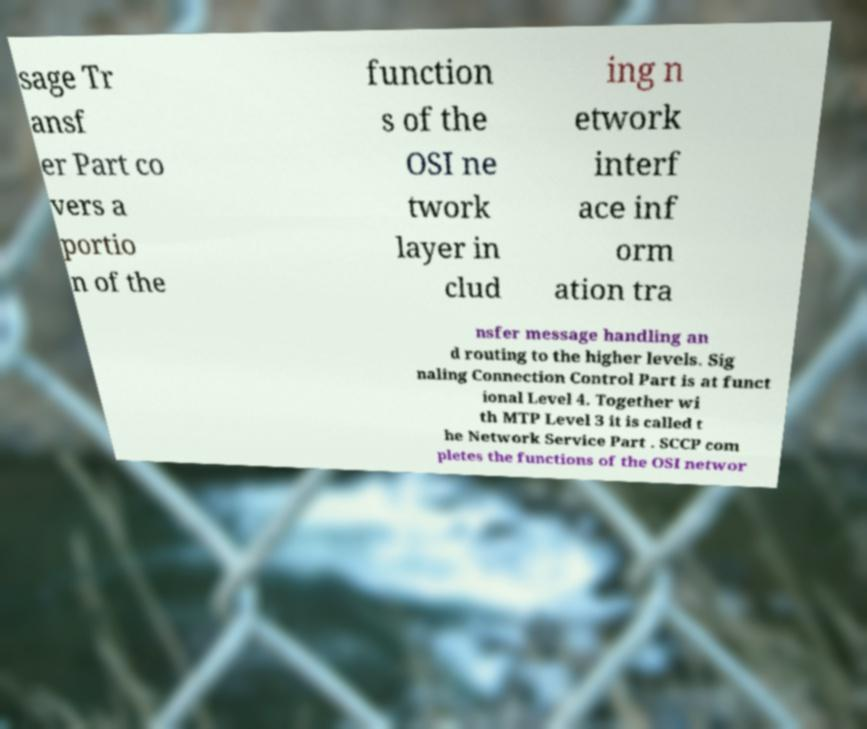Please identify and transcribe the text found in this image. sage Tr ansf er Part co vers a portio n of the function s of the OSI ne twork layer in clud ing n etwork interf ace inf orm ation tra nsfer message handling an d routing to the higher levels. Sig naling Connection Control Part is at funct ional Level 4. Together wi th MTP Level 3 it is called t he Network Service Part . SCCP com pletes the functions of the OSI networ 